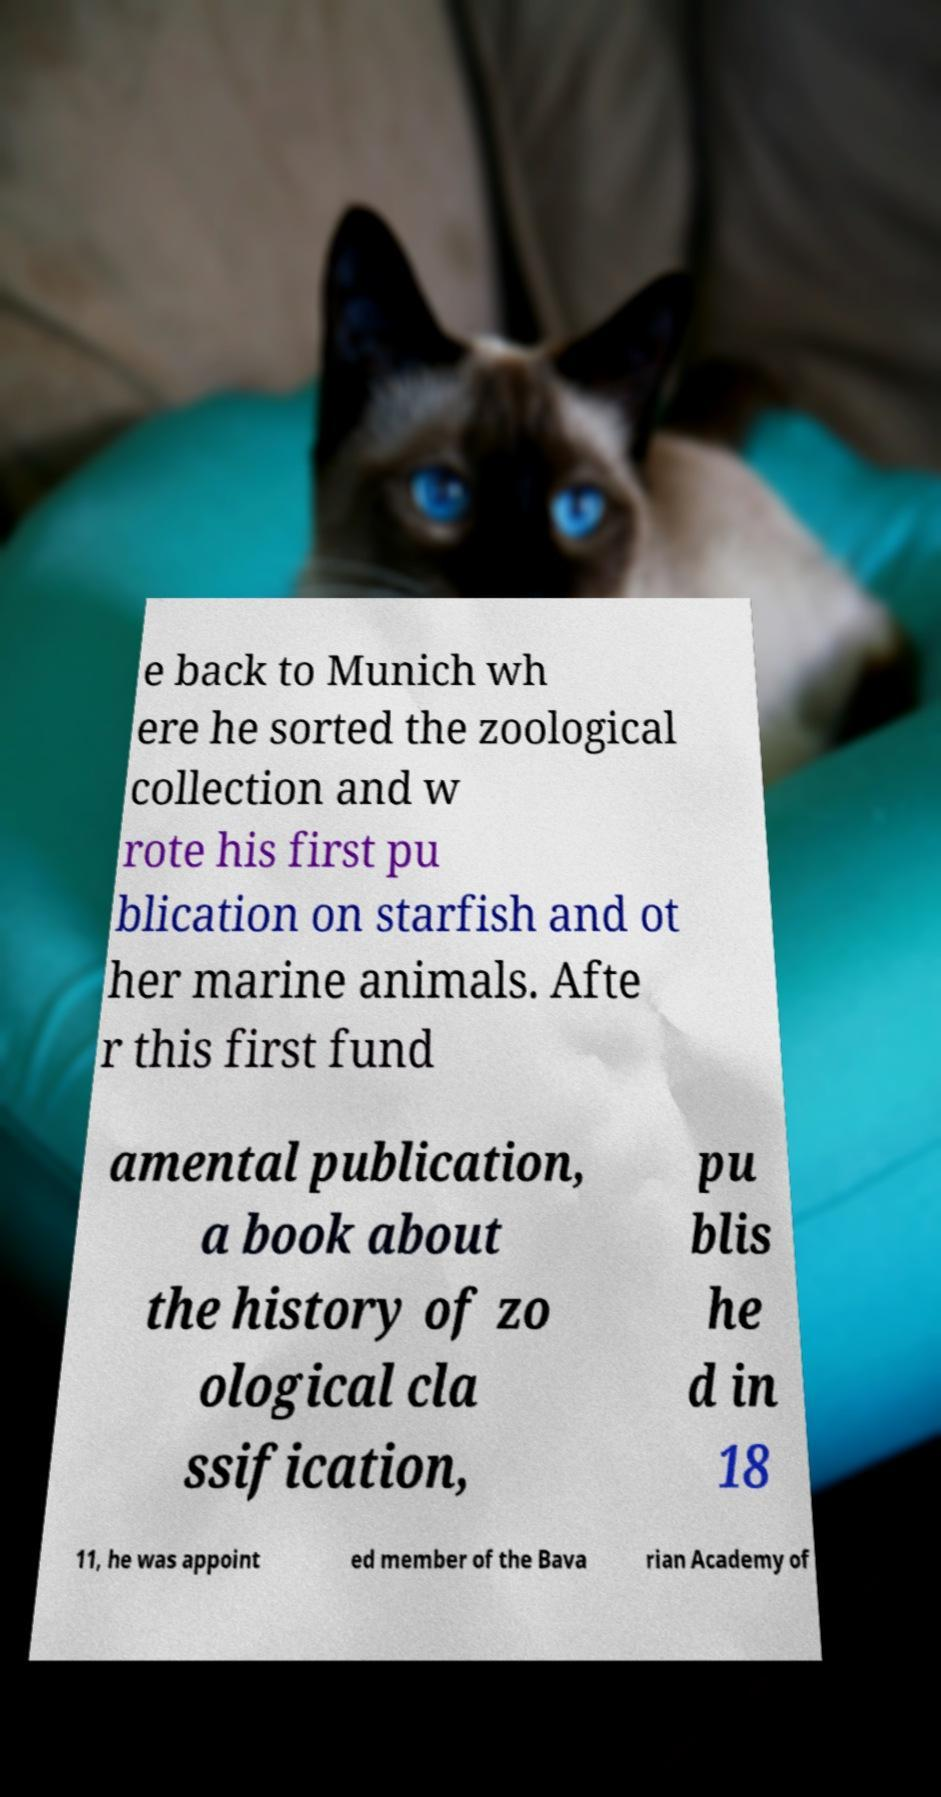Can you accurately transcribe the text from the provided image for me? e back to Munich wh ere he sorted the zoological collection and w rote his first pu blication on starfish and ot her marine animals. Afte r this first fund amental publication, a book about the history of zo ological cla ssification, pu blis he d in 18 11, he was appoint ed member of the Bava rian Academy of 